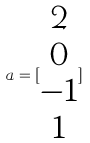<formula> <loc_0><loc_0><loc_500><loc_500>a = [ \begin{matrix} 2 \\ 0 \\ - 1 \\ 1 \end{matrix} ]</formula> 